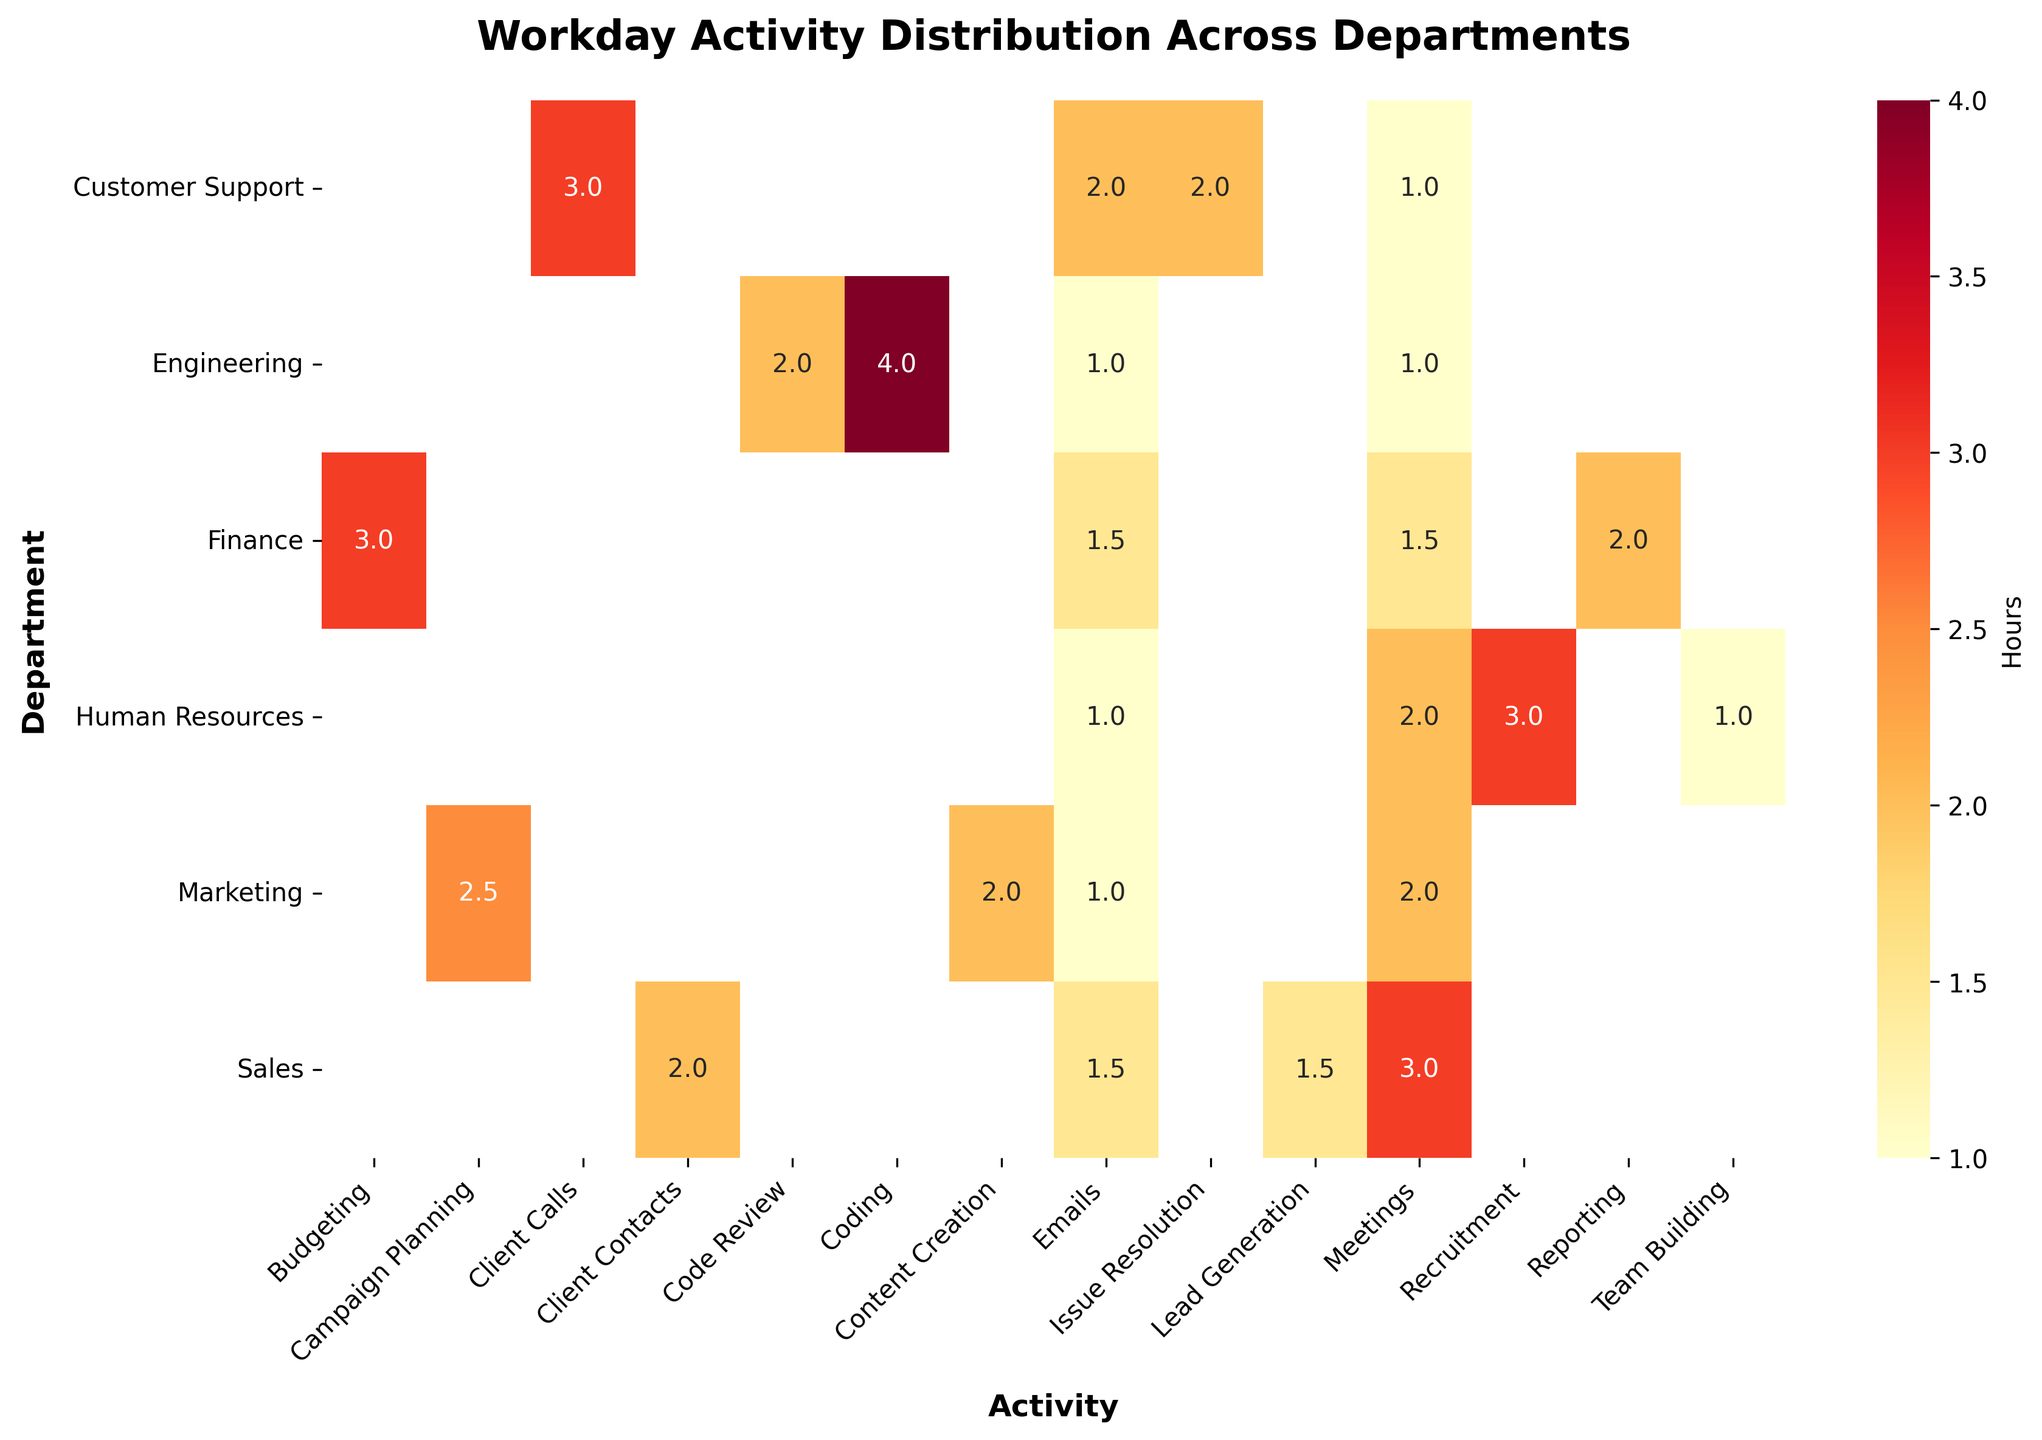What is the title of the heatmap? The title of the heatmap is located at the top center and provides an overview of what the figure represents.
Answer: Workday Activity Distribution Across Departments Which department spends the most hours on Coding? Locate the "Coding" column and find the department row with the highest value in that column.
Answer: Engineering How many hours do Finance and Marketing departments spend on Emails combined? Find the values in the Emails column for Finance and Marketing, then sum them. Finance has 1.5 hours and Marketing has 1 hour. 1.5 + 1 = 2.5
Answer: 2.5 Which activity has the highest average hours across all departments? Calculate the average hours for each activity by summing the hours for each activity across all departments and dividing by the number of departments. Identify the highest value.
Answer: Coding How many departments have at least one activity with more than 2 hours? Check each row and count how many rows have at least one cell with a value greater than 2.
Answer: 5 Which department spends the least amount of time on meetings? Locate the "Meetings" column and identify the department with the smallest value.
Answer: Engineering What's the difference in hours spent on Team Building between Human Resources and Customer Support? Find the values for Team Building in Human Resources and Customer Support, then subtract the smaller value from the larger one. Human Resources has 1 hour and Customer Support has 0 hours. 1 - 0 = 1
Answer: 1 Which activities are unique to only one department in the heatmap? Identify the activities and see if they only appear in one department.
Answer: Recruitment, Budgeting, Reporting, Campaign Planning, Content Creation, Coding, Code Review, Client Calls, Issue Resolution What is the total number of activities shown for the Sales department? Count the number of non-empty cells in the Sales row.
Answer: 4 In which departments do meetings take up more hours than emails? Compare the values in the Meetings and Emails columns for each department and identify those where Meetings > Emails.
Answer: Human Resources, Marketing, Sales 